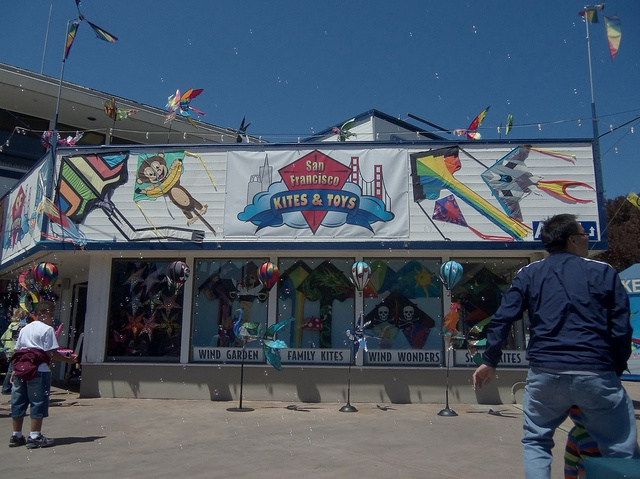Describe the objects in this image and their specific colors. I can see people in blue, black, navy, and gray tones, kite in blue, black, darkgray, gray, and brown tones, people in blue, black, gray, lavender, and maroon tones, kite in blue, tan, green, and black tones, and kite in blue, gray, and darkgray tones in this image. 